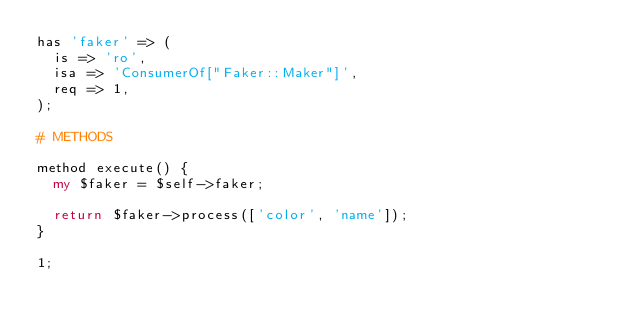Convert code to text. <code><loc_0><loc_0><loc_500><loc_500><_Perl_>has 'faker' => (
  is => 'ro',
  isa => 'ConsumerOf["Faker::Maker"]',
  req => 1,
);

# METHODS

method execute() {
  my $faker = $self->faker;

  return $faker->process(['color', 'name']);
}

1;
</code> 